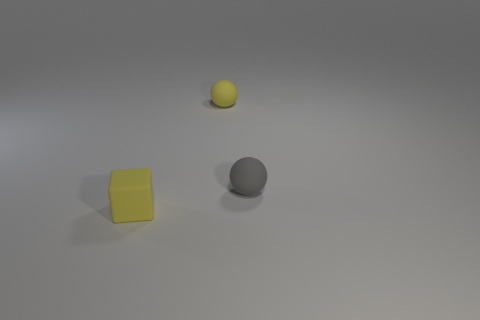What is the shape of the gray object?
Provide a succinct answer. Sphere. There is a small gray matte thing; how many small blocks are right of it?
Give a very brief answer. 0. How many small brown spheres are the same material as the cube?
Provide a short and direct response. 0. Is the material of the object behind the small gray rubber thing the same as the yellow block?
Your answer should be very brief. Yes. Is there a rubber thing?
Offer a very short reply. Yes. There is a rubber thing that is both left of the gray matte ball and to the right of the small rubber block; what is its size?
Provide a succinct answer. Small. Are there more matte cubes behind the yellow rubber ball than small objects that are in front of the small gray thing?
Offer a terse response. No. There is a rubber ball that is the same color as the block; what size is it?
Give a very brief answer. Small. The tiny cube has what color?
Provide a succinct answer. Yellow. What color is the thing that is on the right side of the tiny yellow matte cube and in front of the yellow ball?
Provide a short and direct response. Gray. 